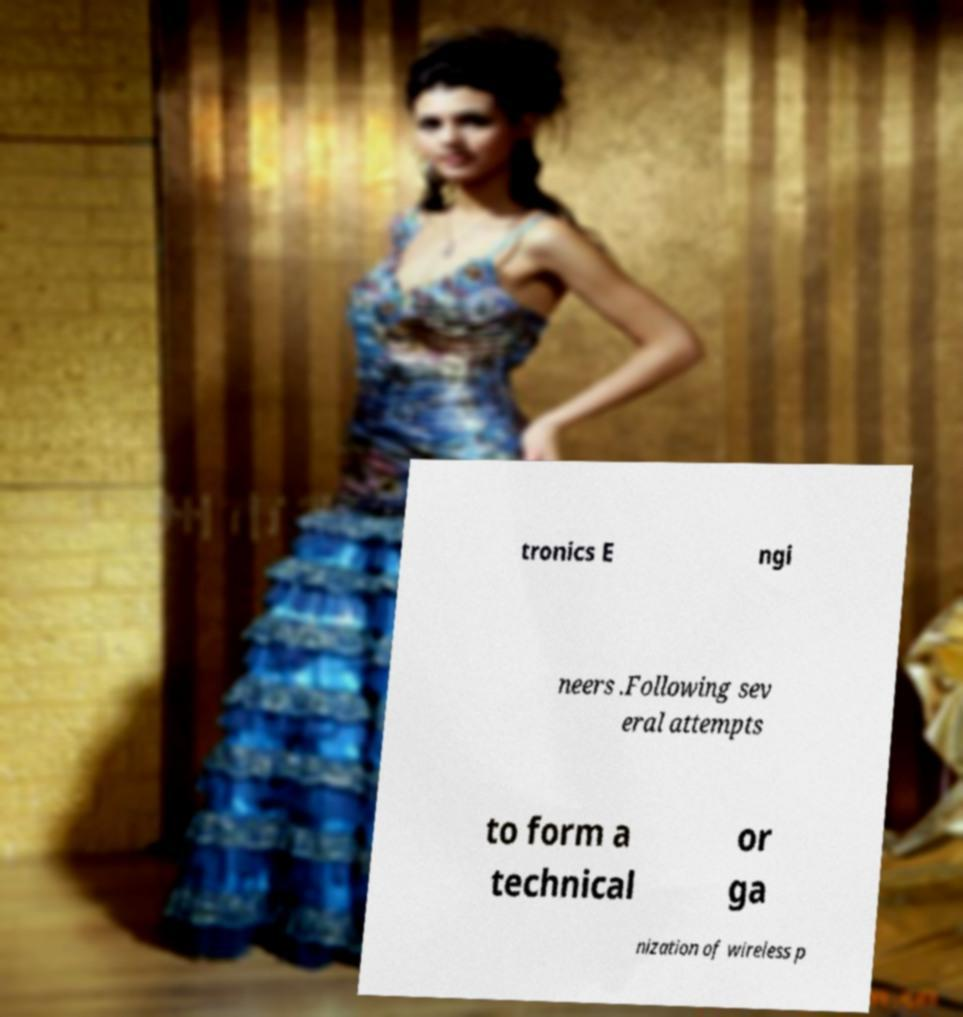Could you extract and type out the text from this image? tronics E ngi neers .Following sev eral attempts to form a technical or ga nization of wireless p 